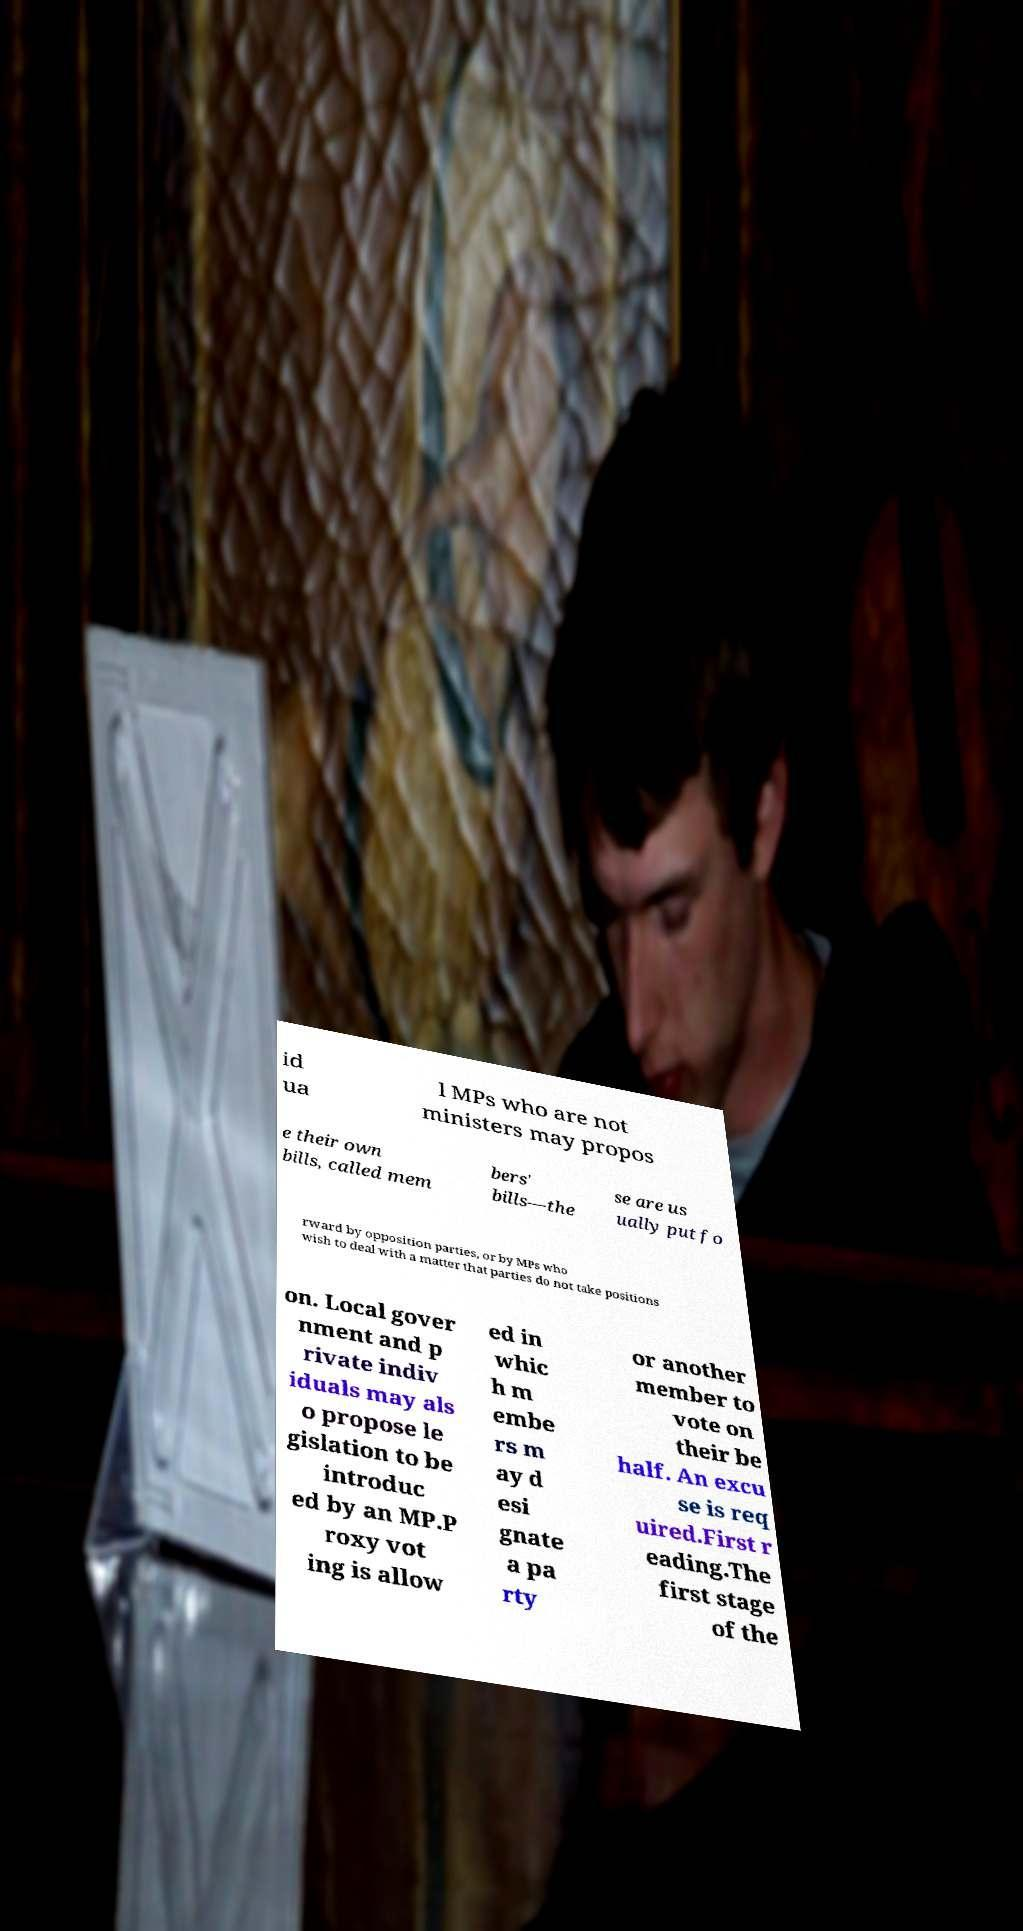Could you assist in decoding the text presented in this image and type it out clearly? id ua l MPs who are not ministers may propos e their own bills, called mem bers' bills—the se are us ually put fo rward by opposition parties, or by MPs who wish to deal with a matter that parties do not take positions on. Local gover nment and p rivate indiv iduals may als o propose le gislation to be introduc ed by an MP.P roxy vot ing is allow ed in whic h m embe rs m ay d esi gnate a pa rty or another member to vote on their be half. An excu se is req uired.First r eading.The first stage of the 